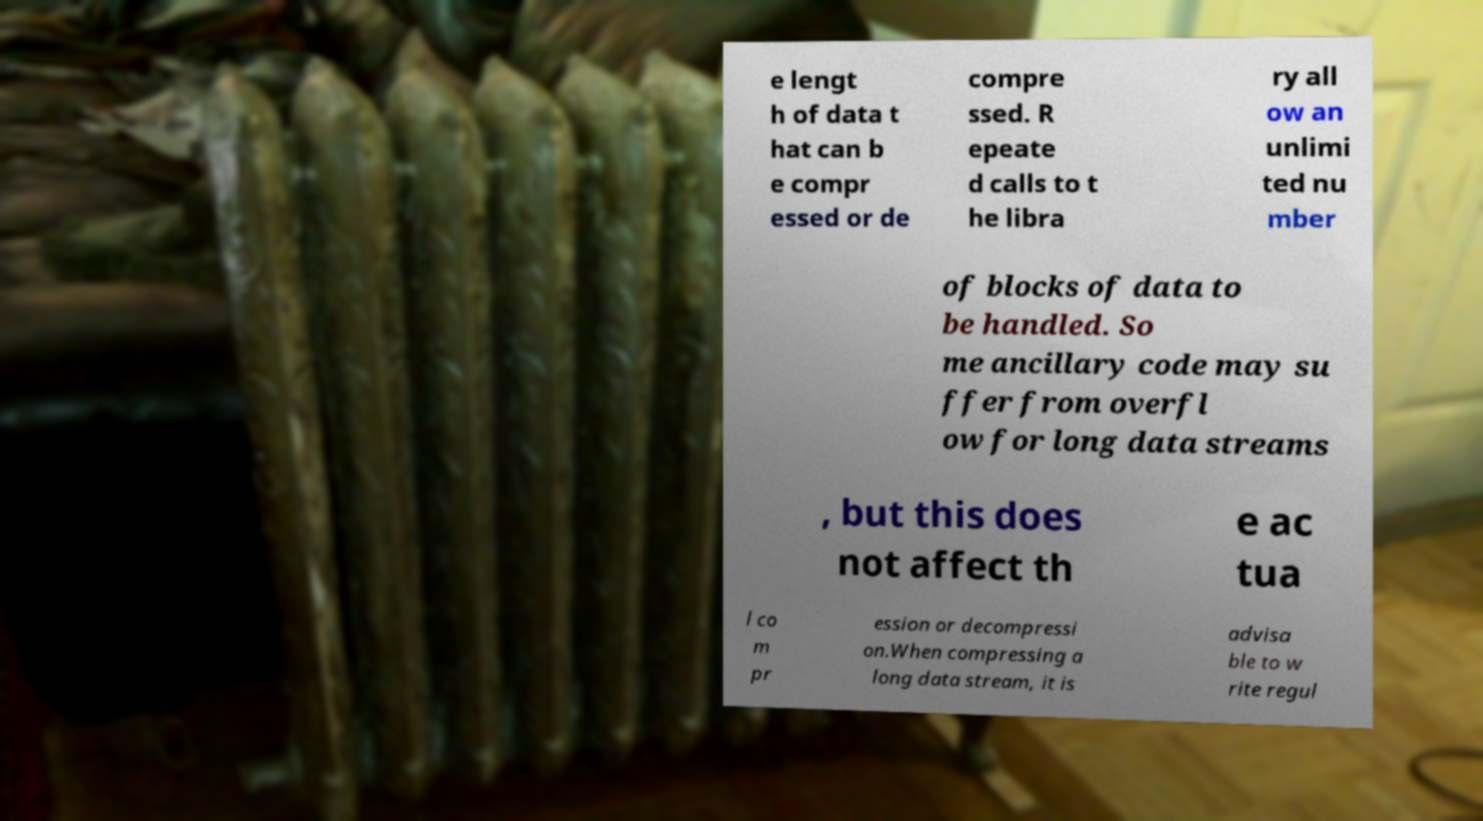Please read and relay the text visible in this image. What does it say? e lengt h of data t hat can b e compr essed or de compre ssed. R epeate d calls to t he libra ry all ow an unlimi ted nu mber of blocks of data to be handled. So me ancillary code may su ffer from overfl ow for long data streams , but this does not affect th e ac tua l co m pr ession or decompressi on.When compressing a long data stream, it is advisa ble to w rite regul 